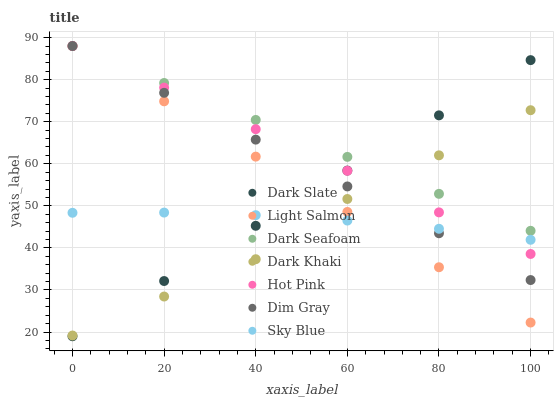Does Dark Khaki have the minimum area under the curve?
Answer yes or no. Yes. Does Dark Seafoam have the maximum area under the curve?
Answer yes or no. Yes. Does Dim Gray have the minimum area under the curve?
Answer yes or no. No. Does Dim Gray have the maximum area under the curve?
Answer yes or no. No. Is Hot Pink the smoothest?
Answer yes or no. Yes. Is Dark Khaki the roughest?
Answer yes or no. Yes. Is Dim Gray the smoothest?
Answer yes or no. No. Is Dim Gray the roughest?
Answer yes or no. No. Does Dark Slate have the lowest value?
Answer yes or no. Yes. Does Dim Gray have the lowest value?
Answer yes or no. No. Does Dark Seafoam have the highest value?
Answer yes or no. Yes. Does Dark Khaki have the highest value?
Answer yes or no. No. Is Sky Blue less than Dark Seafoam?
Answer yes or no. Yes. Is Dark Seafoam greater than Sky Blue?
Answer yes or no. Yes. Does Dim Gray intersect Hot Pink?
Answer yes or no. Yes. Is Dim Gray less than Hot Pink?
Answer yes or no. No. Is Dim Gray greater than Hot Pink?
Answer yes or no. No. Does Sky Blue intersect Dark Seafoam?
Answer yes or no. No. 